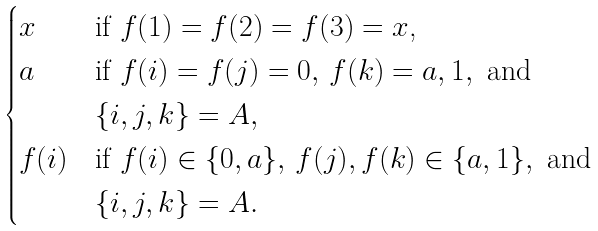Convert formula to latex. <formula><loc_0><loc_0><loc_500><loc_500>\begin{cases} x & \text {if $f(1)=f(2)=f(3)=x$,} \\ a & \text {if } f ( i ) = f ( j ) = 0 , \, f ( k ) = a , 1 , \text { and} \\ & \{ i , j , k \} = A , \\ f ( i ) & \text {if } f ( i ) \in \{ 0 , a \} , \, f ( j ) , f ( k ) \in \{ a , 1 \} , \text { and} \\ & \{ i , j , k \} = A . \end{cases}</formula> 